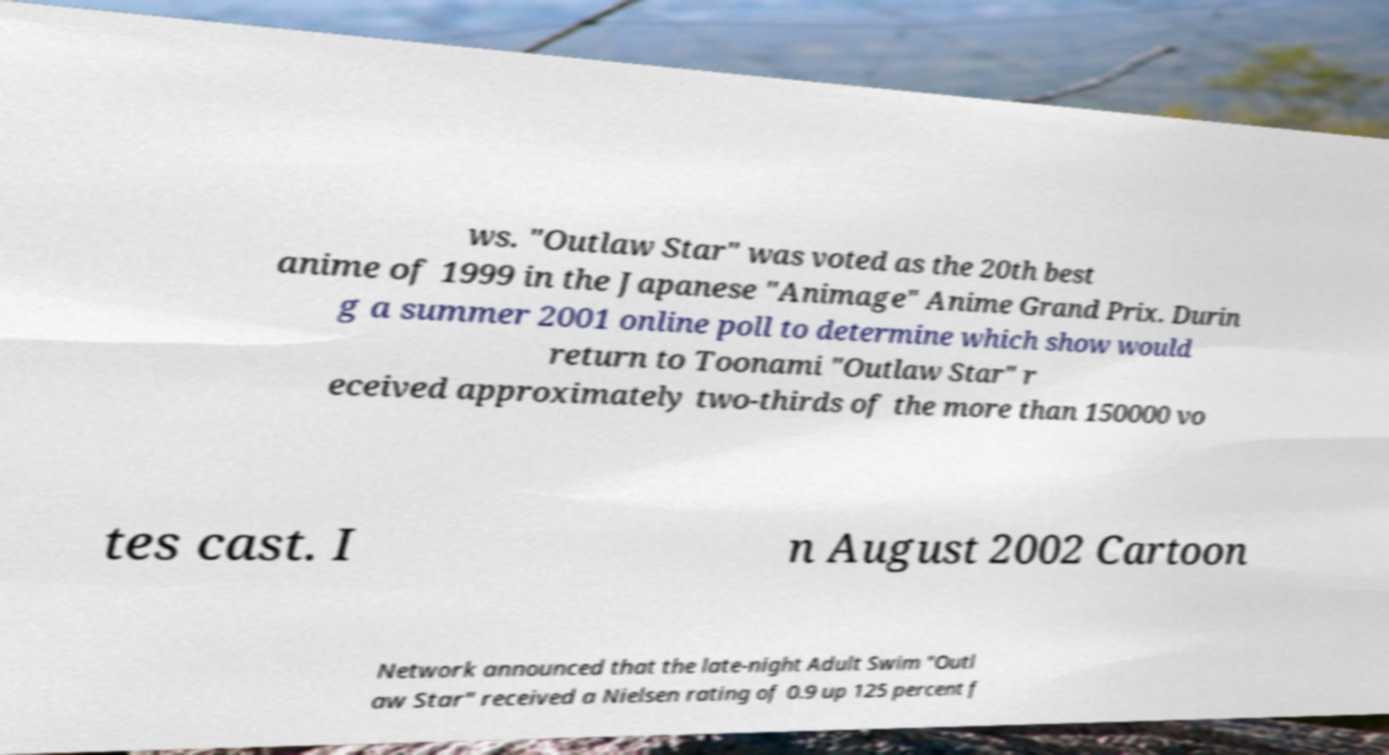Could you assist in decoding the text presented in this image and type it out clearly? ws. "Outlaw Star" was voted as the 20th best anime of 1999 in the Japanese "Animage" Anime Grand Prix. Durin g a summer 2001 online poll to determine which show would return to Toonami "Outlaw Star" r eceived approximately two-thirds of the more than 150000 vo tes cast. I n August 2002 Cartoon Network announced that the late-night Adult Swim "Outl aw Star" received a Nielsen rating of 0.9 up 125 percent f 